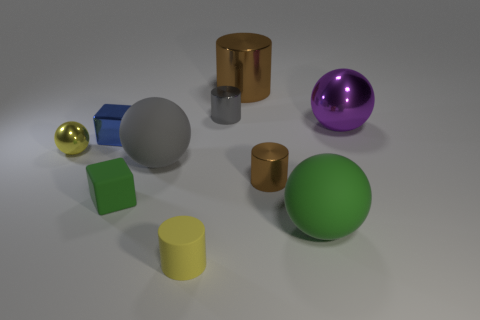Subtract all cylinders. How many objects are left? 6 Add 7 big cubes. How many big cubes exist? 7 Subtract 0 red cubes. How many objects are left? 10 Subtract all large matte spheres. Subtract all tiny gray metallic cylinders. How many objects are left? 7 Add 3 purple balls. How many purple balls are left? 4 